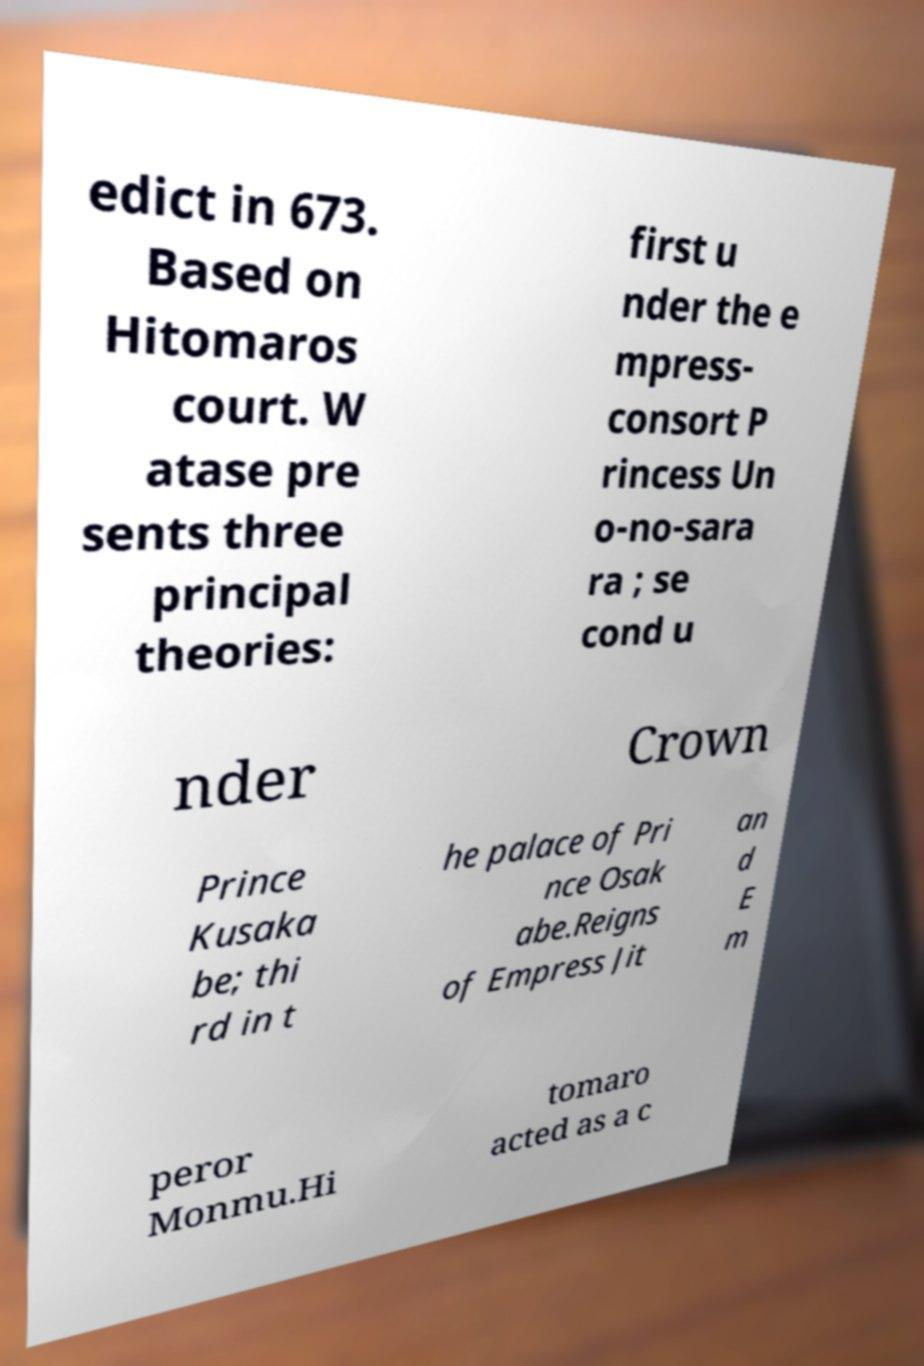Please identify and transcribe the text found in this image. edict in 673. Based on Hitomaros court. W atase pre sents three principal theories: first u nder the e mpress- consort P rincess Un o-no-sara ra ; se cond u nder Crown Prince Kusaka be; thi rd in t he palace of Pri nce Osak abe.Reigns of Empress Jit an d E m peror Monmu.Hi tomaro acted as a c 